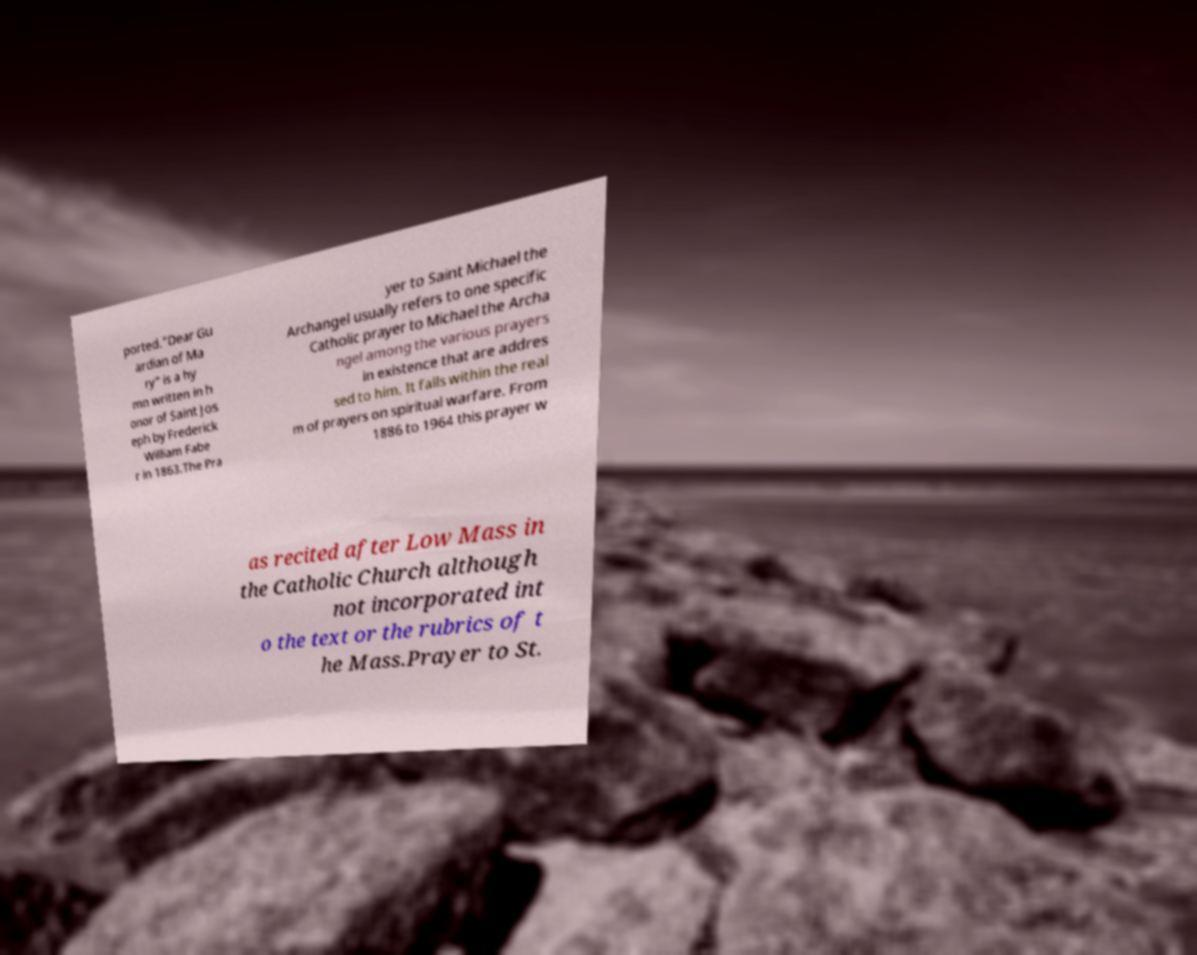Could you assist in decoding the text presented in this image and type it out clearly? ported."Dear Gu ardian of Ma ry" is a hy mn written in h onor of Saint Jos eph by Frederick William Fabe r in 1863.The Pra yer to Saint Michael the Archangel usually refers to one specific Catholic prayer to Michael the Archa ngel among the various prayers in existence that are addres sed to him. It falls within the real m of prayers on spiritual warfare. From 1886 to 1964 this prayer w as recited after Low Mass in the Catholic Church although not incorporated int o the text or the rubrics of t he Mass.Prayer to St. 